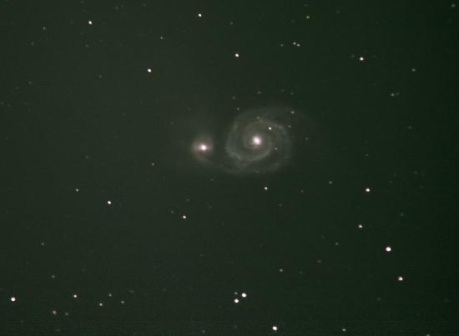Could you estimate how many stars are depicted in this image, and what does that say about the scale of the galaxy? Estimating the exact number of stars in this image is challenging without precise measurements, but visually, we can see dozens of stars within this small view of the cosmos. This offers a glimpse into the vastness of a spiral galaxy like the one shown here, which may contain billions of stars. The mere fraction we observe suggests an immense scale, with the full expanse of the galaxy extending far beyond the frame of the image. Each star we see could represent a solar system of its own, possibly with planets and other celestial bodies orbiting them, highlighting the incredible scale and diversity found within galaxies. 